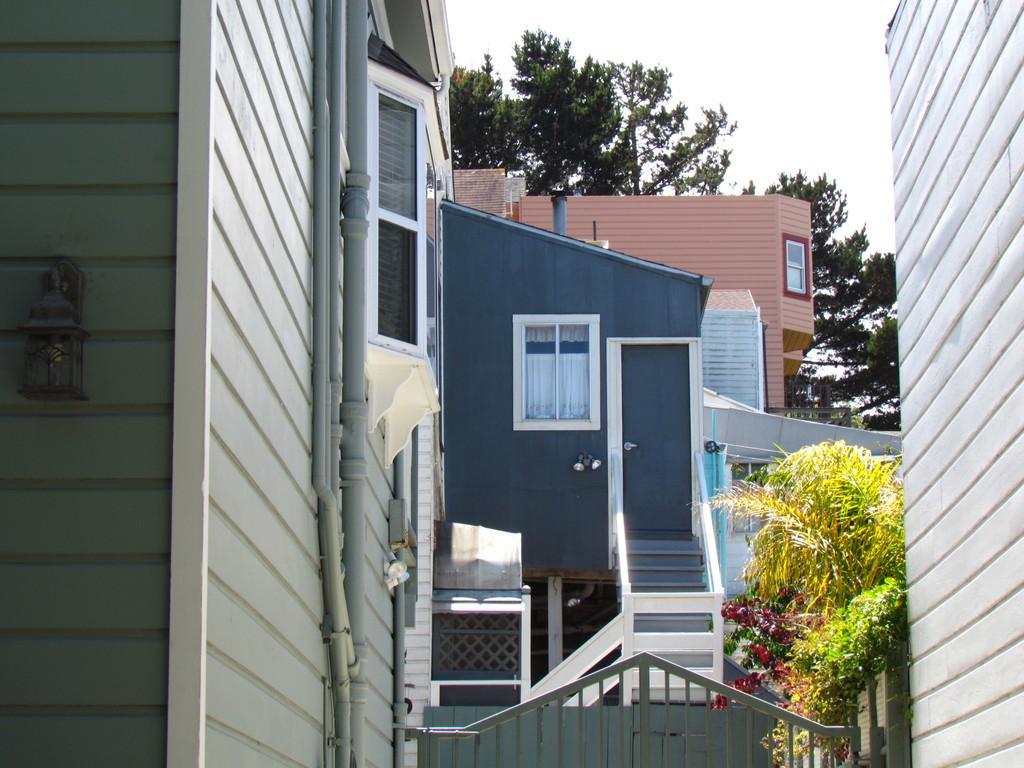Could you give a brief overview of what you see in this image? In the picture I can see the buildings and I can see the glass windows of the building. There are pipelines on the wall of the building on the left side. I can see a decorative lamp on the wall on the extreme left side. I can see the metal gate at the bottom of the picture. I can see the flowering plants on the right side. In the background, I can see the trees. 